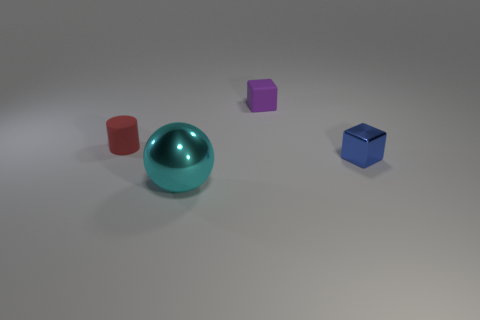Add 2 big yellow matte objects. How many objects exist? 6 Subtract all cylinders. How many objects are left? 3 Subtract 1 cubes. How many cubes are left? 1 Add 3 blue metallic blocks. How many blue metallic blocks are left? 4 Add 1 objects. How many objects exist? 5 Subtract 1 red cylinders. How many objects are left? 3 Subtract all purple cubes. Subtract all purple spheres. How many cubes are left? 1 Subtract all cyan objects. Subtract all large yellow metal cubes. How many objects are left? 3 